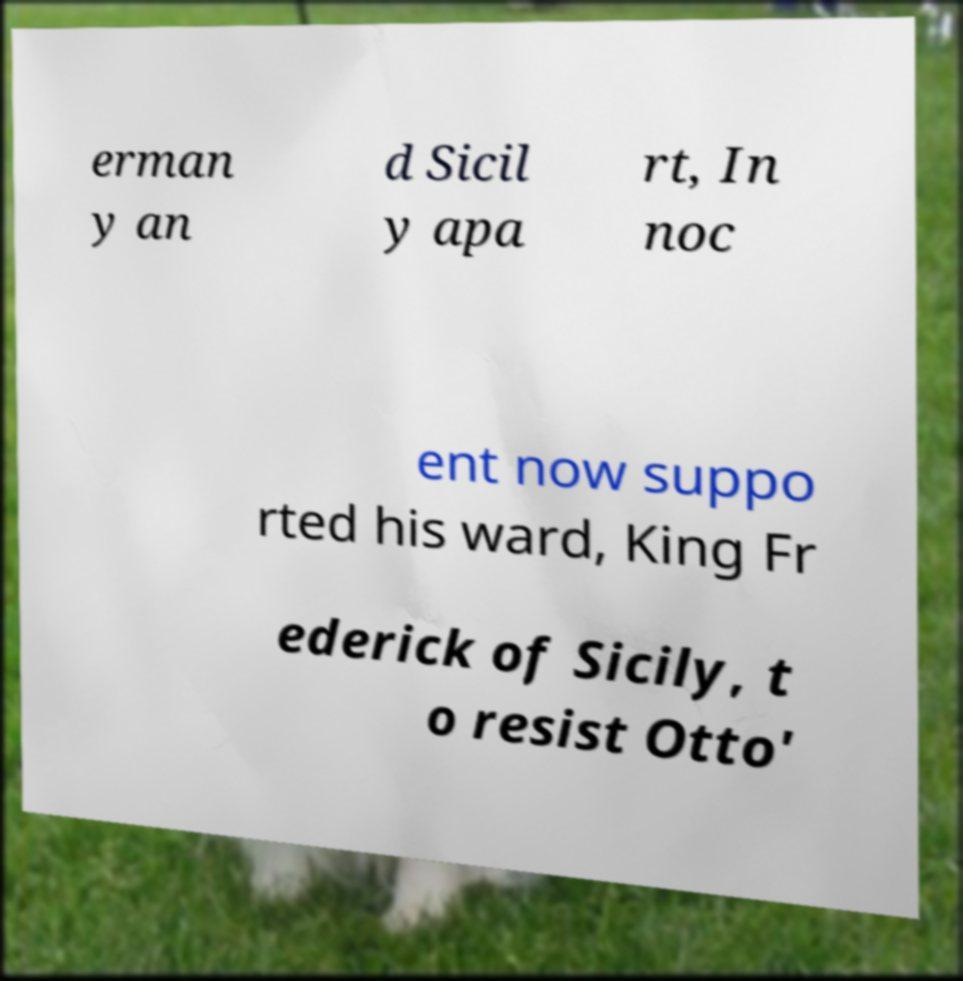Could you assist in decoding the text presented in this image and type it out clearly? erman y an d Sicil y apa rt, In noc ent now suppo rted his ward, King Fr ederick of Sicily, t o resist Otto' 